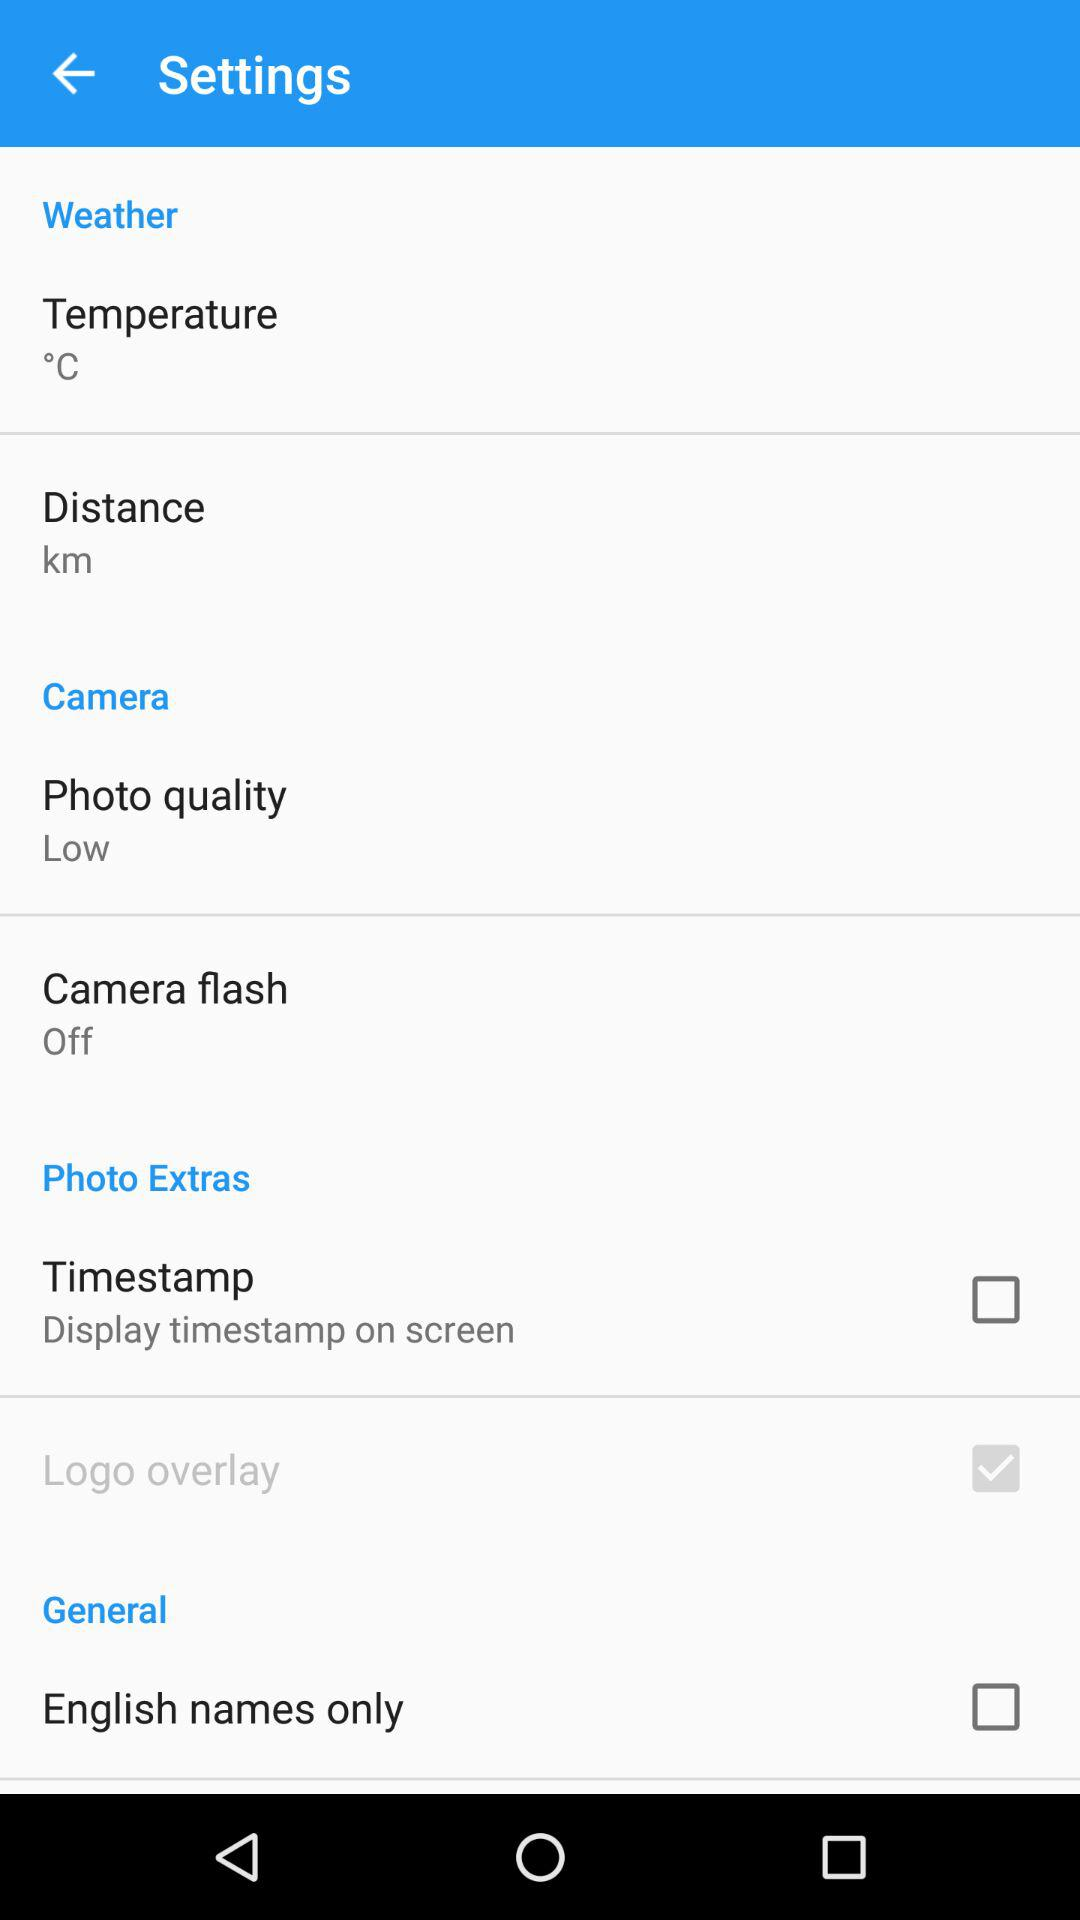How many items have a checkbox in the Photo Extras section?
Answer the question using a single word or phrase. 2 